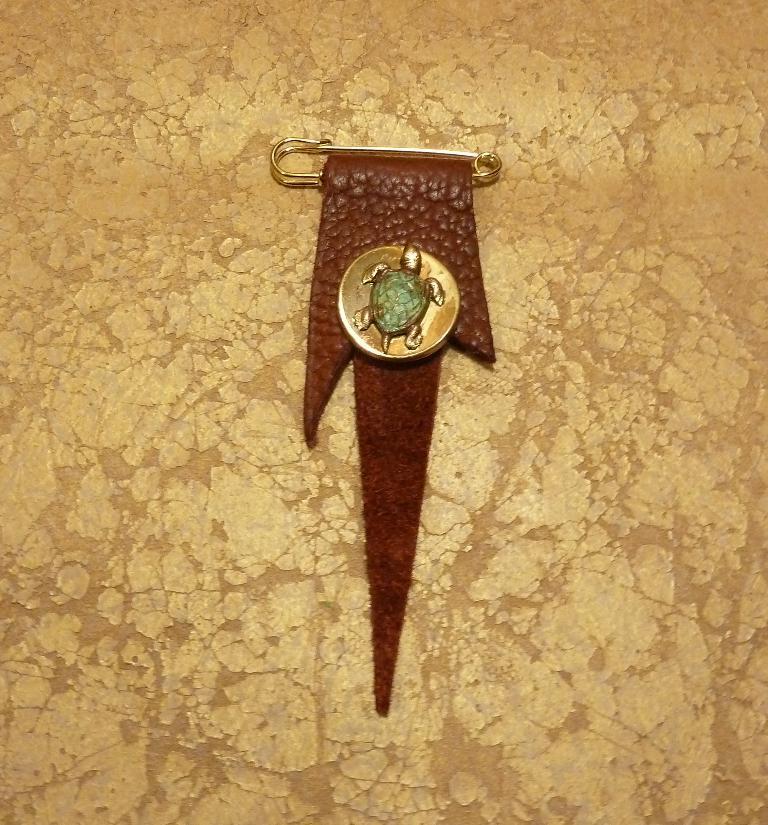Describe this image in one or two sentences. In the picture we can see a cloth on it we can see a pin with a batch and on it we can see a turtle symbol. 